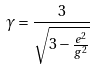Convert formula to latex. <formula><loc_0><loc_0><loc_500><loc_500>\gamma = \frac { 3 } { \sqrt { 3 - \frac { e ^ { 2 } } { g ^ { 2 } } } }</formula> 